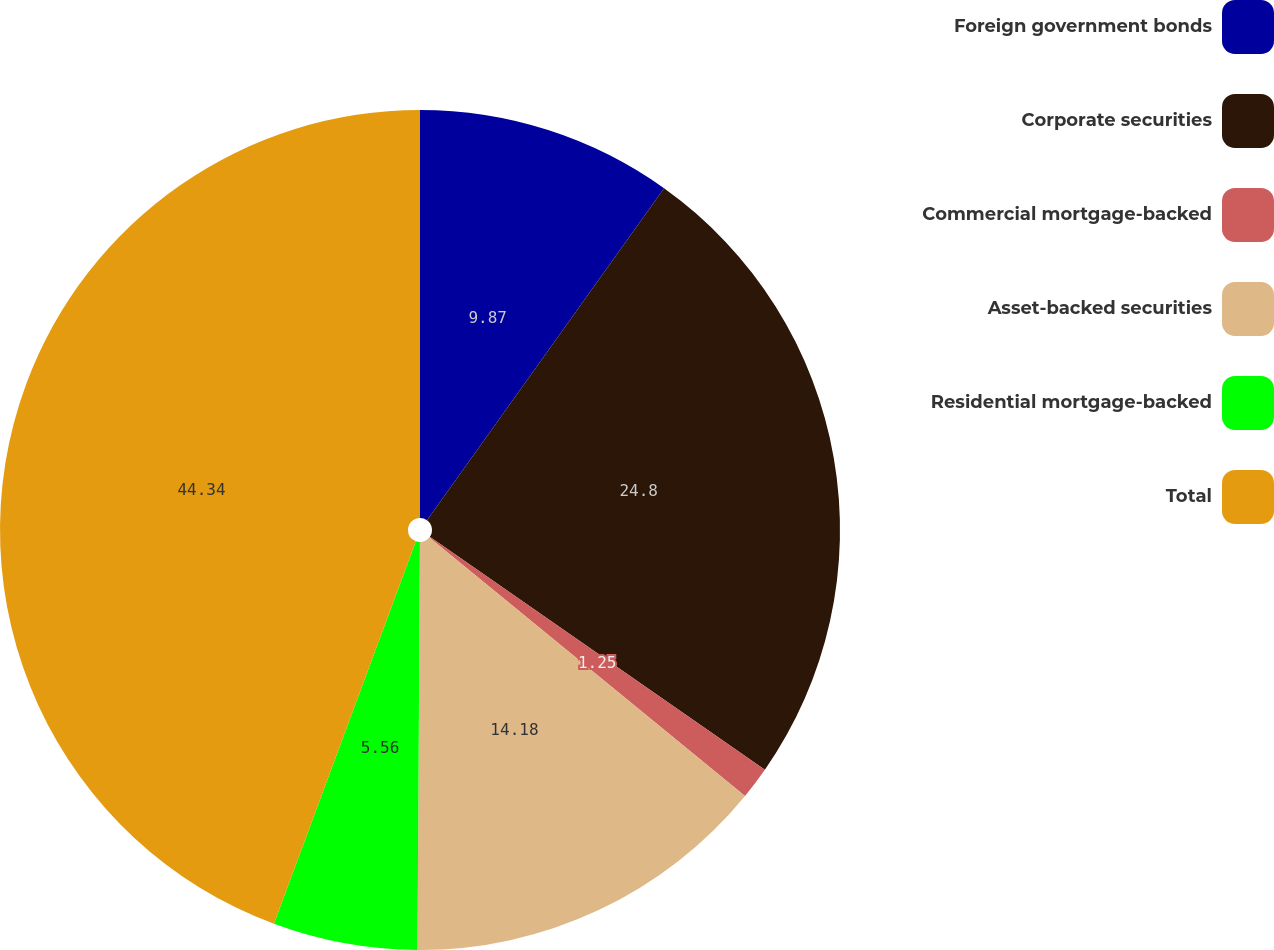Convert chart. <chart><loc_0><loc_0><loc_500><loc_500><pie_chart><fcel>Foreign government bonds<fcel>Corporate securities<fcel>Commercial mortgage-backed<fcel>Asset-backed securities<fcel>Residential mortgage-backed<fcel>Total<nl><fcel>9.87%<fcel>24.8%<fcel>1.25%<fcel>14.18%<fcel>5.56%<fcel>44.35%<nl></chart> 